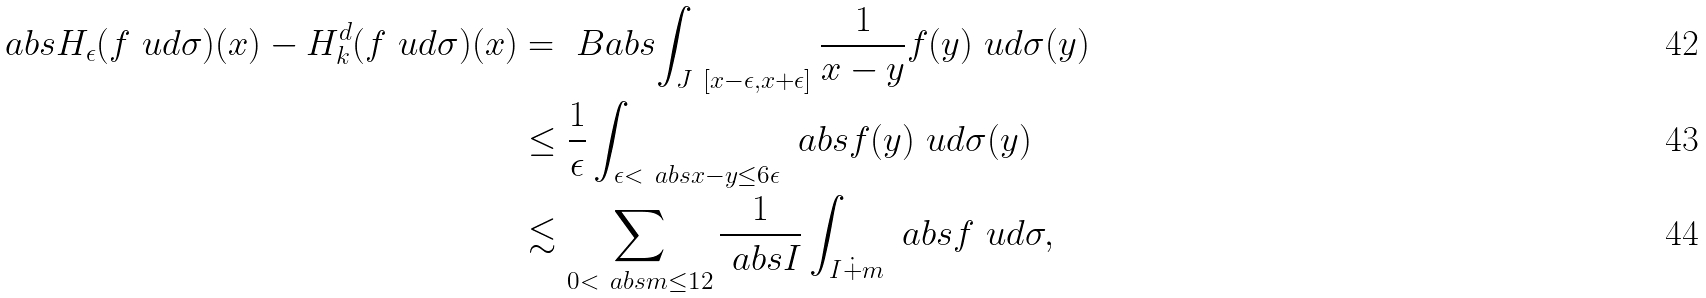<formula> <loc_0><loc_0><loc_500><loc_500>\ a b s { H _ { \epsilon } ( f \ u d \sigma ) ( x ) - H ^ { d } _ { k } ( f \ u d \sigma ) ( x ) } & = \ B a b s { \int _ { J \ [ x - \epsilon , x + \epsilon ] } \frac { 1 } { x - y } f ( y ) \ u d \sigma ( y ) } \\ & \leq \frac { 1 } { \epsilon } \int _ { \epsilon < \ a b s { x - y } \leq 6 \epsilon } \ a b s { f ( y ) } \ u d \sigma ( y ) \\ & \lesssim \sum _ { 0 < \ a b s { m } \leq 1 2 } \frac { 1 } { \ a b s { I } } \int _ { I \dot { + } m } \ a b s { f } \ u d \sigma ,</formula> 